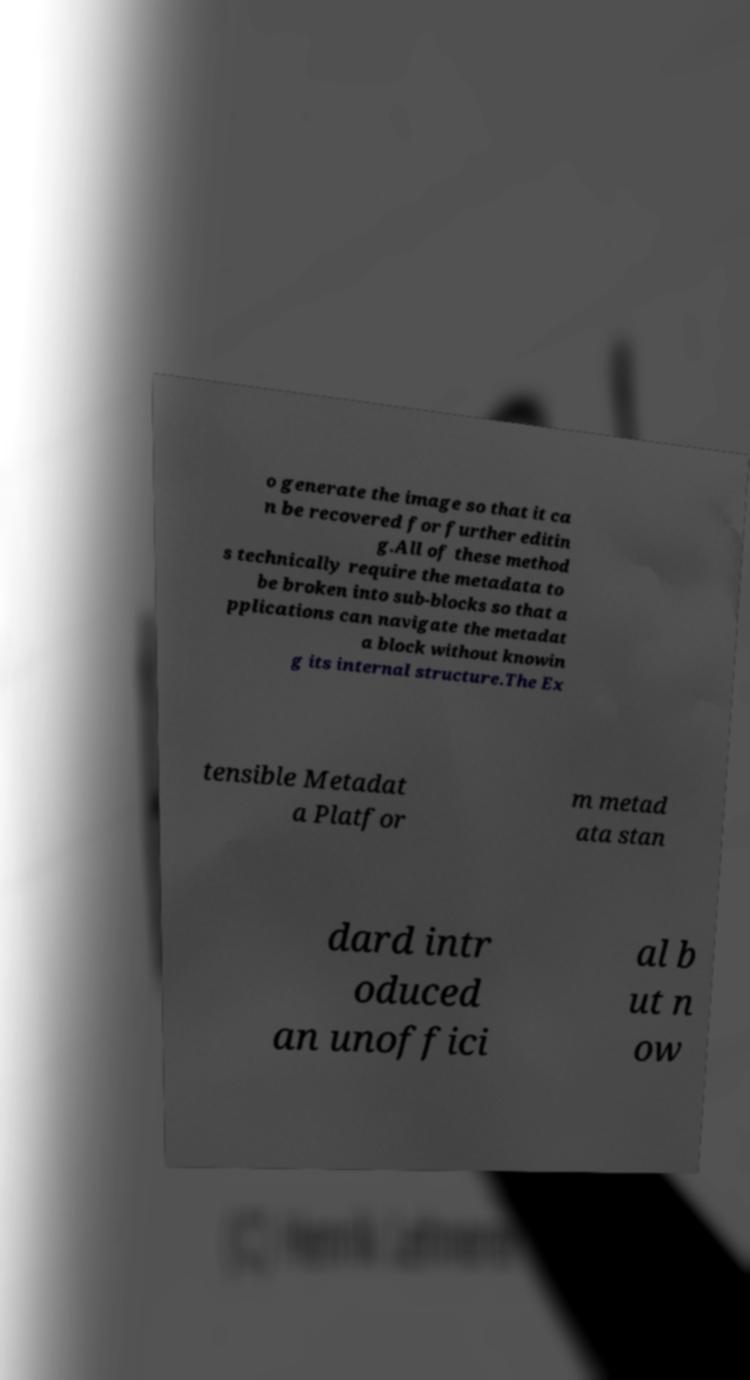Can you accurately transcribe the text from the provided image for me? o generate the image so that it ca n be recovered for further editin g.All of these method s technically require the metadata to be broken into sub-blocks so that a pplications can navigate the metadat a block without knowin g its internal structure.The Ex tensible Metadat a Platfor m metad ata stan dard intr oduced an unoffici al b ut n ow 